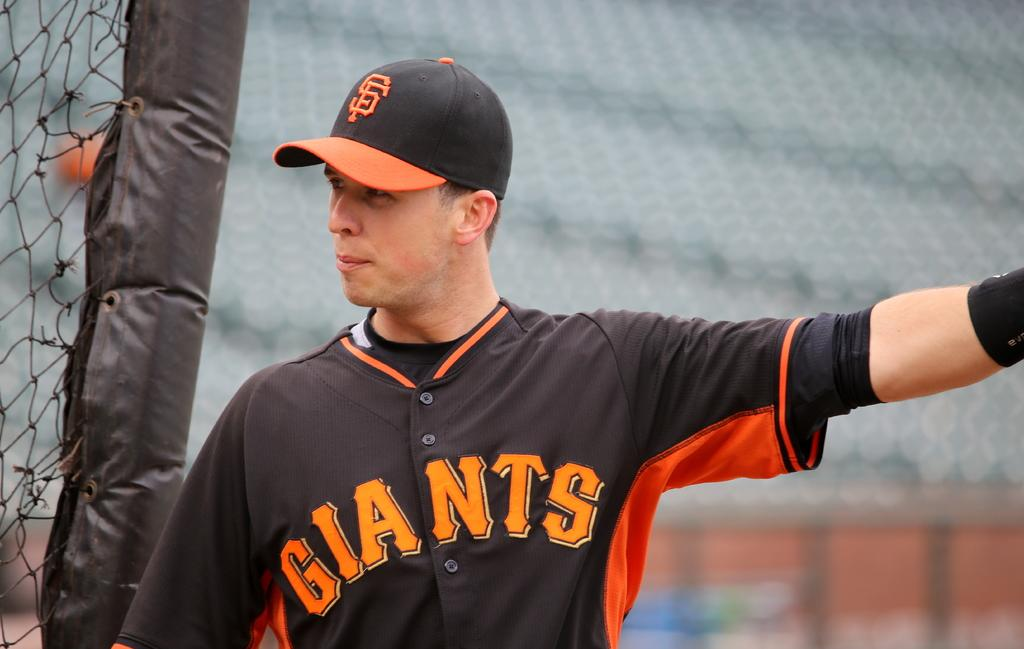What is the main subject of the image? There is a man standing in the center of the image. What is the man wearing on his head? The man is wearing a cap. What can be seen on the right side of the image? There is a net on the right side of the image. What type of field can be seen in the image? There is no field present in the image; it features a man standing in the center and a net on the right side. What is the man's hope for the future in the image? The image does not provide any information about the man's hopes or aspirations. 